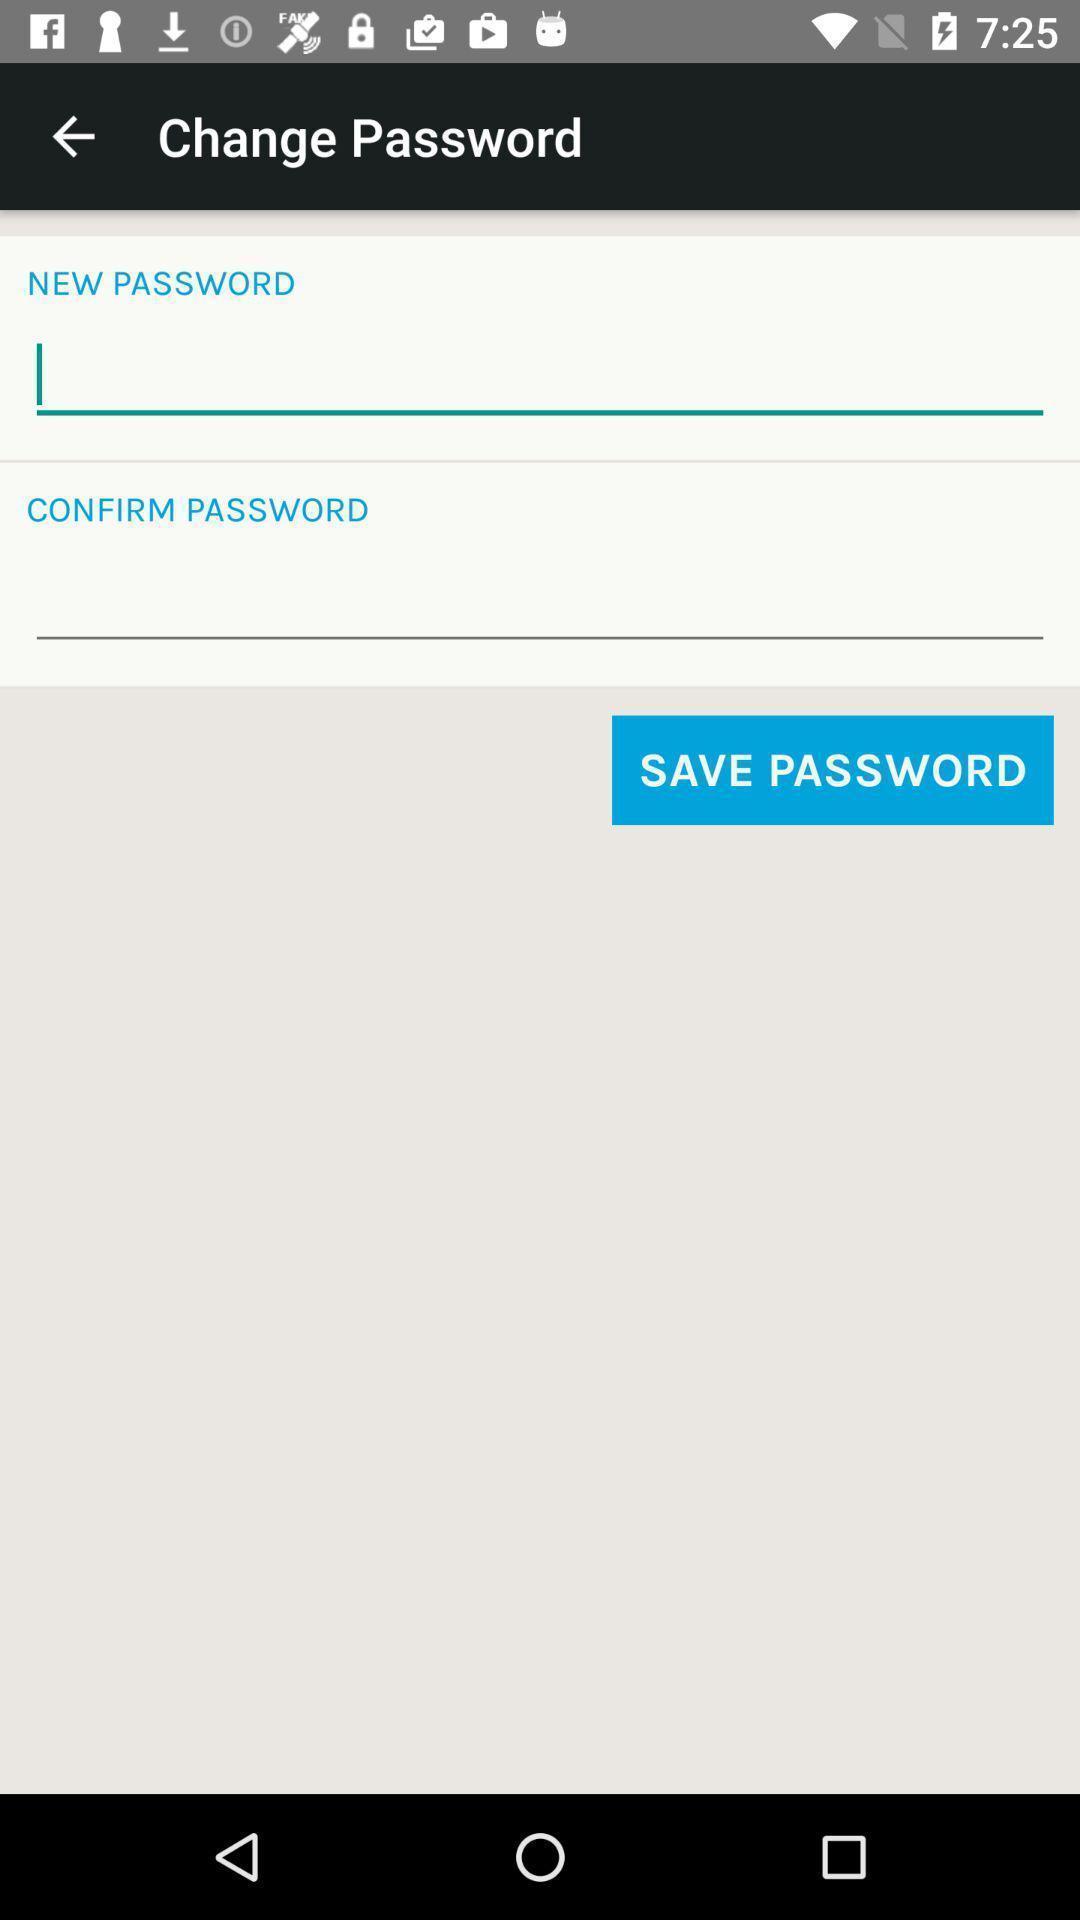Tell me about the visual elements in this screen capture. Screen shows change password options. 